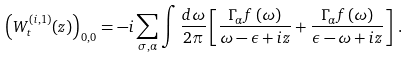<formula> <loc_0><loc_0><loc_500><loc_500>\left ( W _ { t } ^ { ( i , 1 ) } ( z ) \right ) _ { 0 , 0 } = - i \sum _ { \sigma , \alpha } \int \frac { d \omega } { 2 \pi } \left [ \frac { \Gamma _ { \alpha } f \left ( \omega \right ) } { \omega - \epsilon + i z } + \frac { \Gamma _ { \alpha } f \left ( \omega \right ) } { \epsilon - \omega + i z } \right ] \, .</formula> 